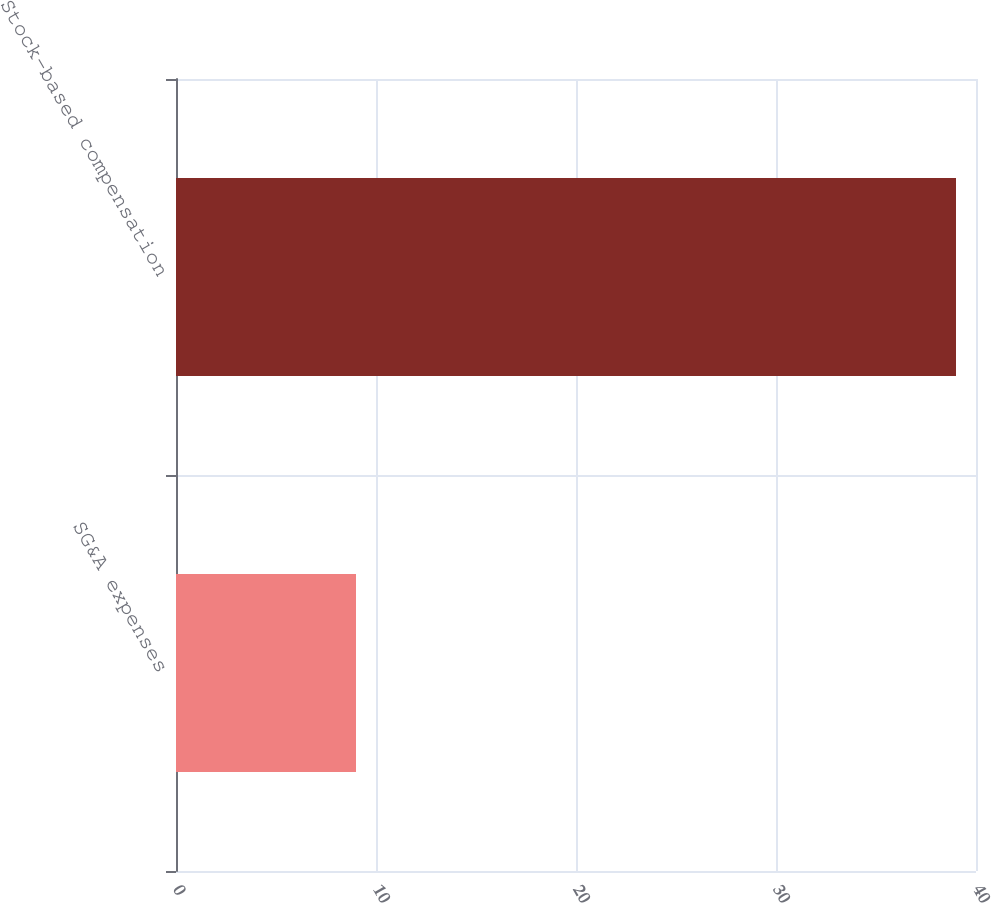Convert chart. <chart><loc_0><loc_0><loc_500><loc_500><bar_chart><fcel>SG&A expenses<fcel>Stock-based compensation<nl><fcel>9<fcel>39<nl></chart> 